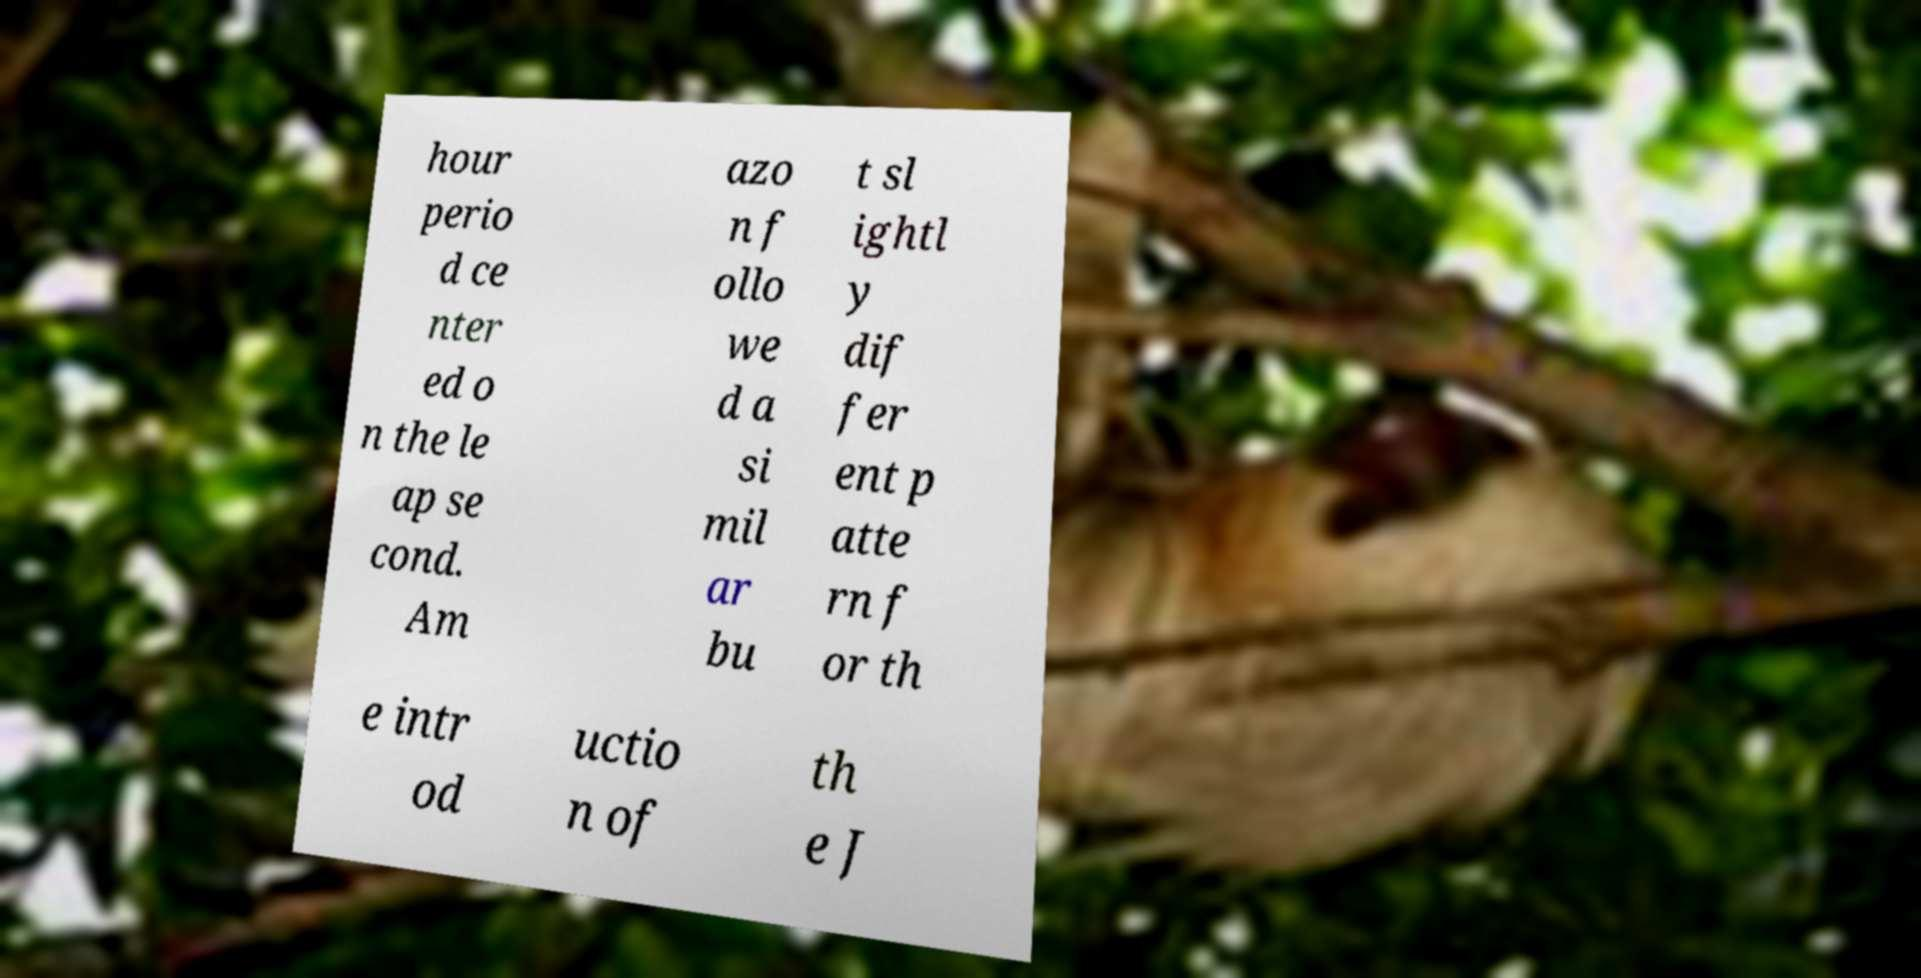Could you assist in decoding the text presented in this image and type it out clearly? hour perio d ce nter ed o n the le ap se cond. Am azo n f ollo we d a si mil ar bu t sl ightl y dif fer ent p atte rn f or th e intr od uctio n of th e J 